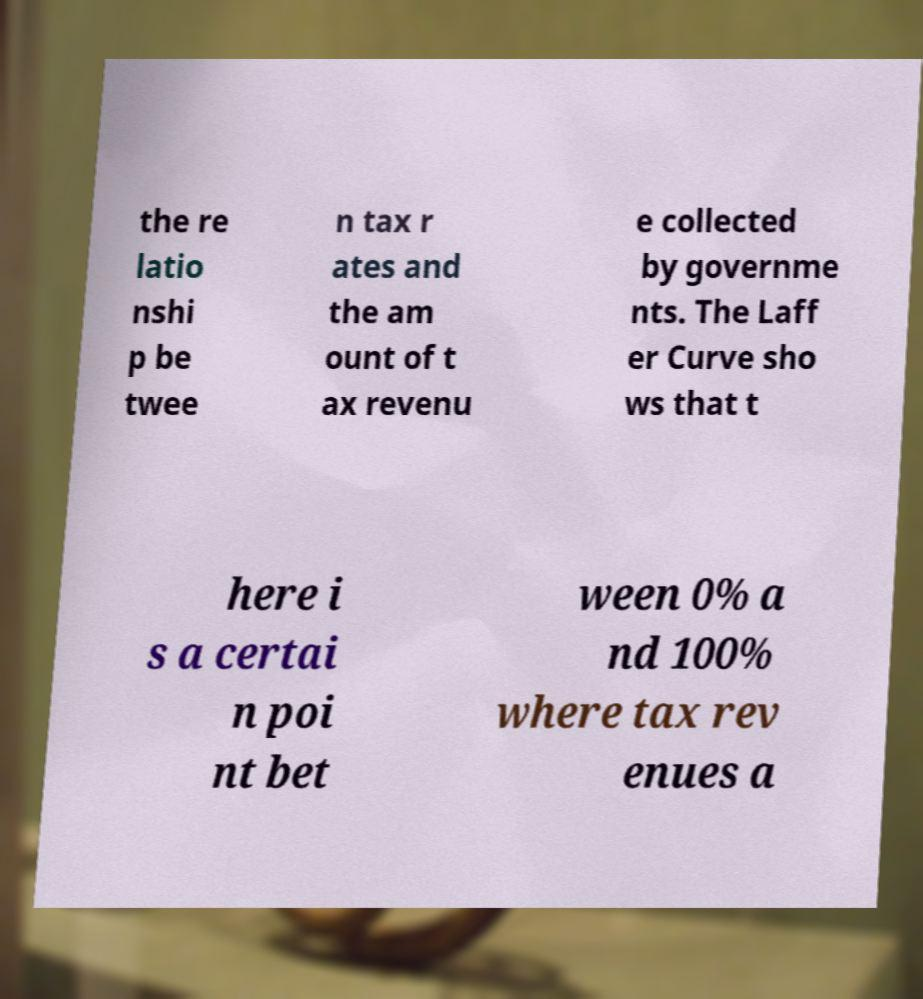Could you extract and type out the text from this image? the re latio nshi p be twee n tax r ates and the am ount of t ax revenu e collected by governme nts. The Laff er Curve sho ws that t here i s a certai n poi nt bet ween 0% a nd 100% where tax rev enues a 